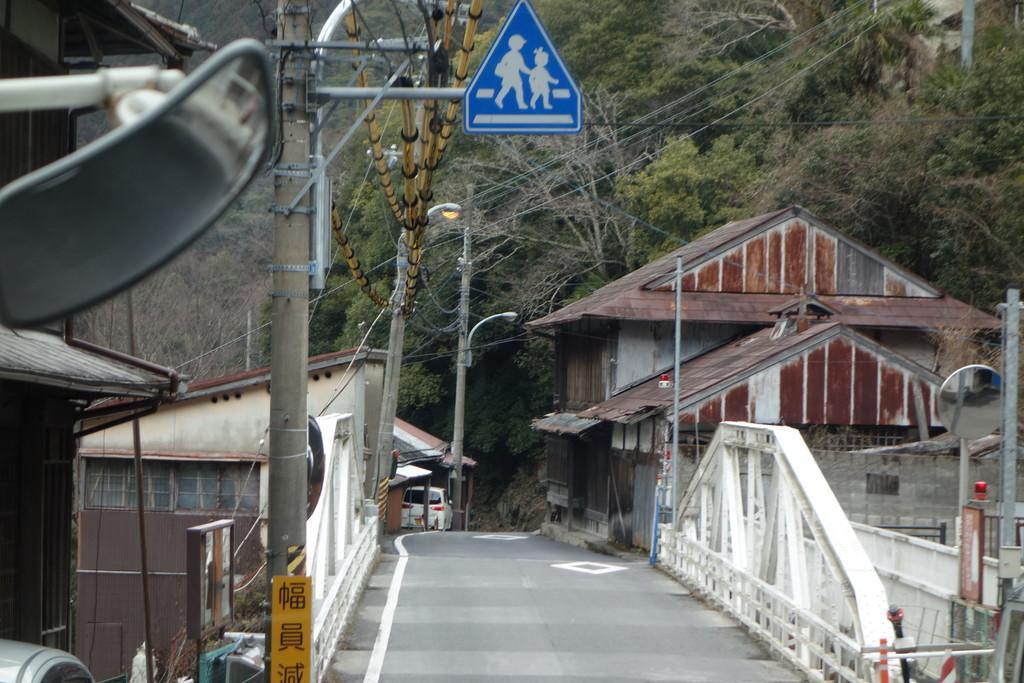Please provide a concise description of this image. In the image in the center we can see poles,sign boards,mirrors,banners,fences,vehicles etc. In the background we can see trees and buildings. 